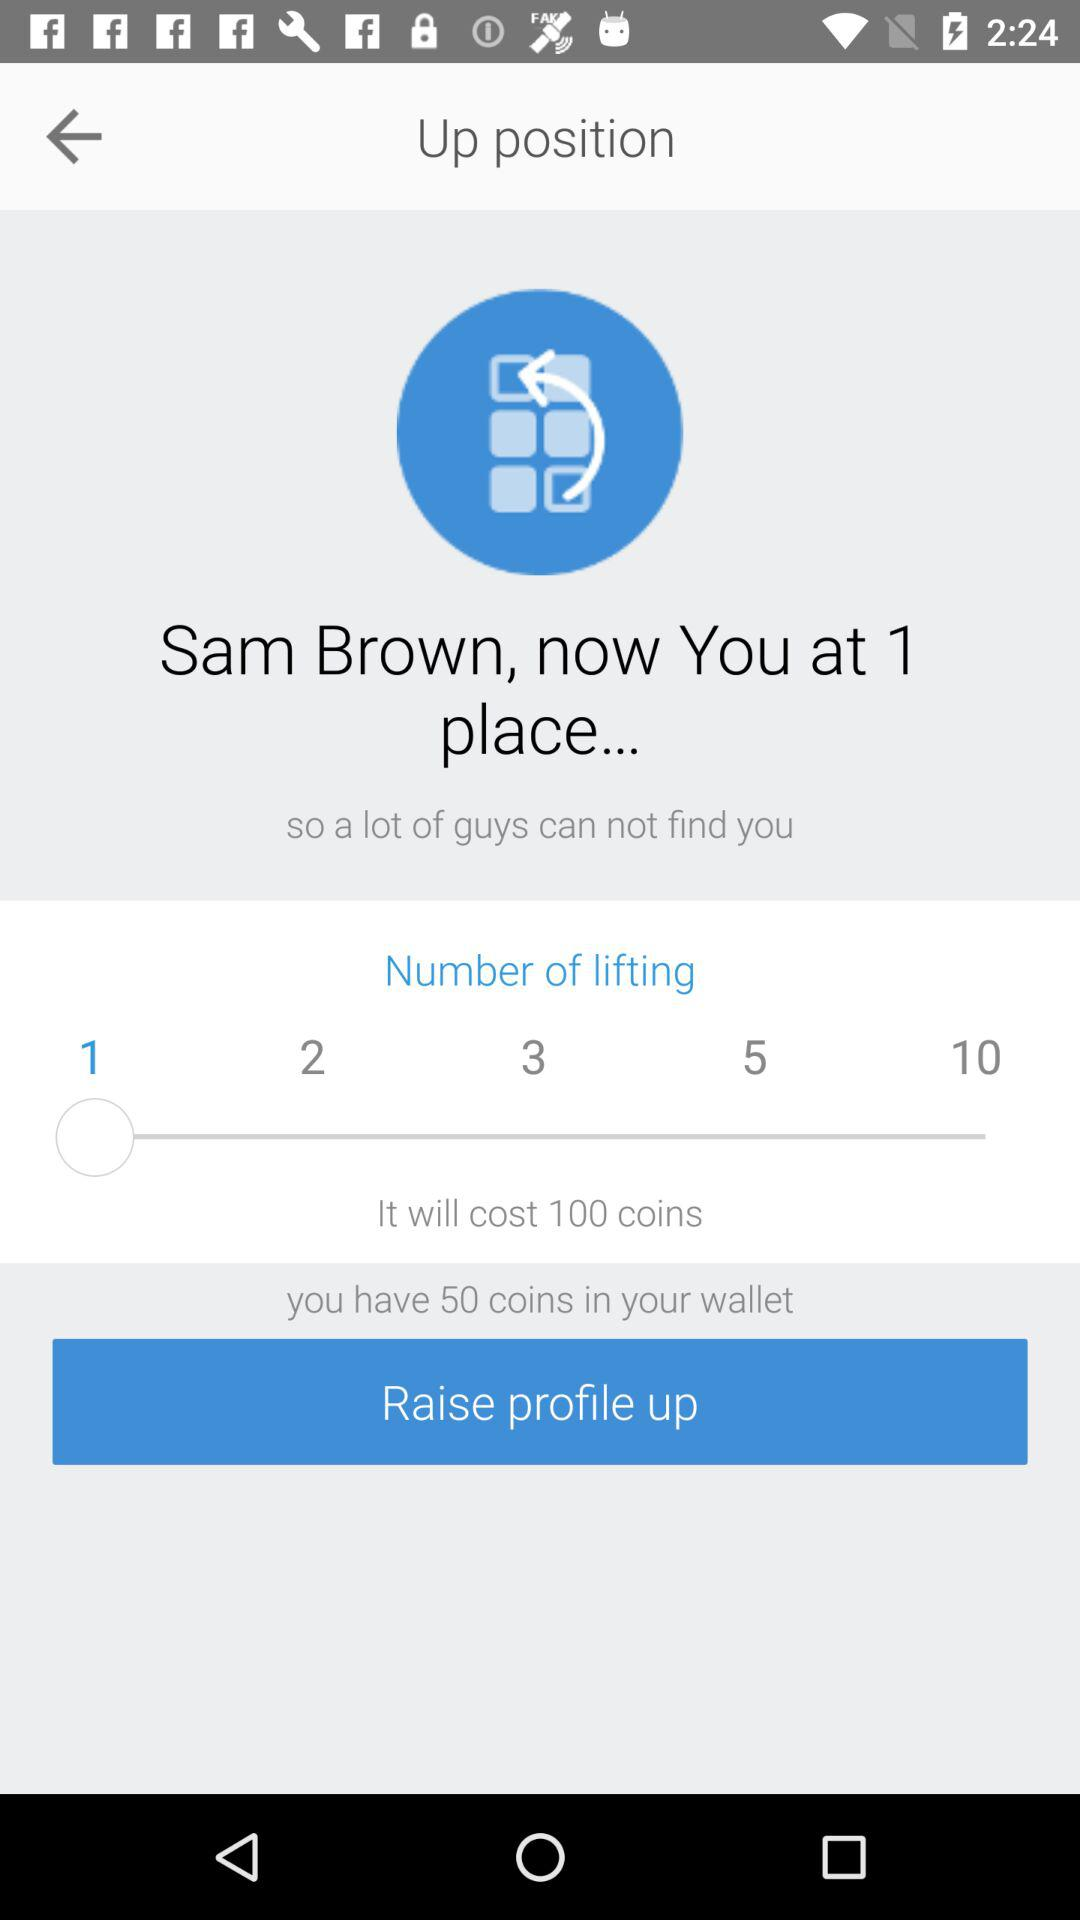How many more coins do I need to raise my profile up?
Answer the question using a single word or phrase. 50 